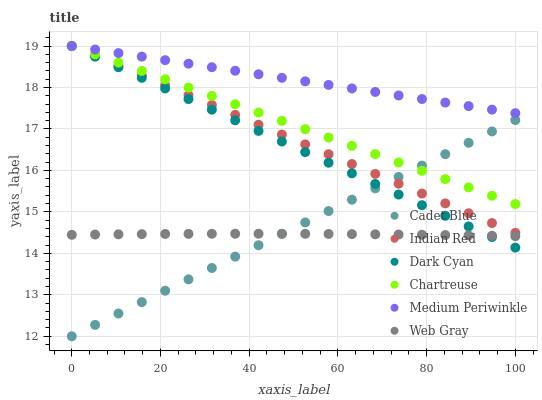Does Web Gray have the minimum area under the curve?
Answer yes or no. Yes. Does Medium Periwinkle have the maximum area under the curve?
Answer yes or no. Yes. Does Chartreuse have the minimum area under the curve?
Answer yes or no. No. Does Chartreuse have the maximum area under the curve?
Answer yes or no. No. Is Indian Red the smoothest?
Answer yes or no. Yes. Is Web Gray the roughest?
Answer yes or no. Yes. Is Medium Periwinkle the smoothest?
Answer yes or no. No. Is Medium Periwinkle the roughest?
Answer yes or no. No. Does Cadet Blue have the lowest value?
Answer yes or no. Yes. Does Chartreuse have the lowest value?
Answer yes or no. No. Does Dark Cyan have the highest value?
Answer yes or no. Yes. Does Web Gray have the highest value?
Answer yes or no. No. Is Web Gray less than Chartreuse?
Answer yes or no. Yes. Is Indian Red greater than Web Gray?
Answer yes or no. Yes. Does Dark Cyan intersect Web Gray?
Answer yes or no. Yes. Is Dark Cyan less than Web Gray?
Answer yes or no. No. Is Dark Cyan greater than Web Gray?
Answer yes or no. No. Does Web Gray intersect Chartreuse?
Answer yes or no. No. 